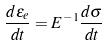Convert formula to latex. <formula><loc_0><loc_0><loc_500><loc_500>\frac { d \epsilon _ { e } } { d t } = E ^ { - 1 } \frac { d \sigma } { d t }</formula> 